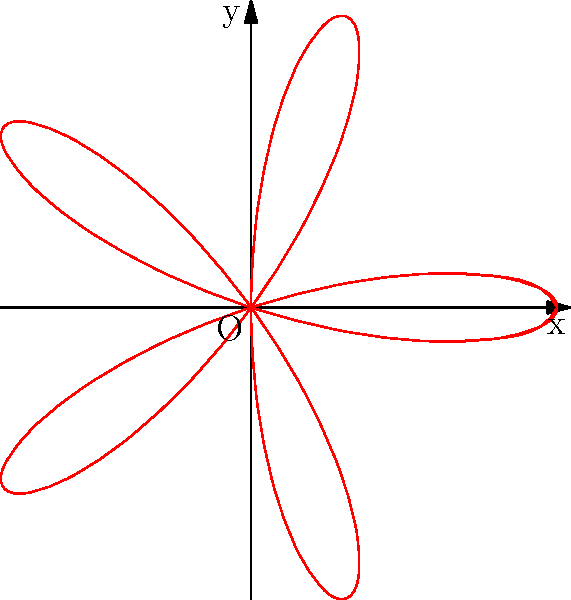In the polar rose pattern representing a raccoon pack's evasion tactics, how many petals are formed, and what does this suggest about their complex behaviors? To determine the number of petals in the polar rose pattern:

1. The polar rose equation is given by $r = a \cos(k\theta)$, where $a$ is the amplitude and $k$ is the frequency.

2. In this case, we can see that $k = 5$ from the Asymptote code.

3. The number of petals in a polar rose is determined by $k$:
   - If $k$ is odd, the number of petals is $k$.
   - If $k$ is even, the number of petals is $2k$.

4. Since $k = 5$, which is odd, the number of petals is 5.

5. In the context of raccoon behavior, each petal could represent a distinct evasion tactic or pattern of movement. The symmetry suggests coordinated group behavior, while the complexity of the shape implies sophisticated strategies.

6. The five petals might represent:
   a) Quick direction changes
   b) Utilizing urban obstacles
   c) Splitting up and regrouping
   d) Distracting pursuers
   e) Using elevated pathways (e.g., trees, rooftops)

This pattern suggests that raccoons employ a diverse set of evasion tactics, working together as a pack to outsmart pursuers through complex, coordinated movements.
Answer: 5 petals; diverse, coordinated evasion tactics 